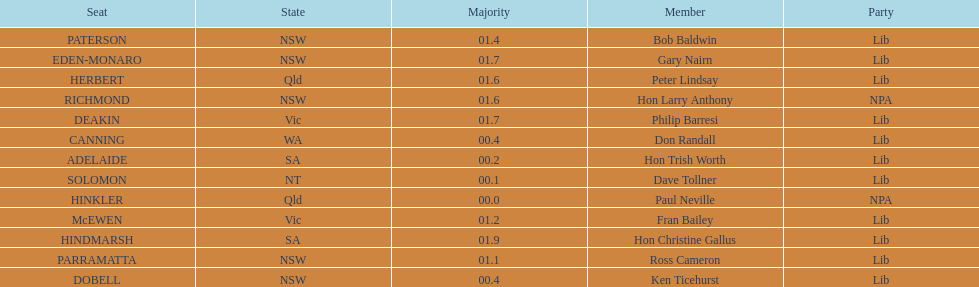What was the total majority that the dobell seat had? 00.4. 